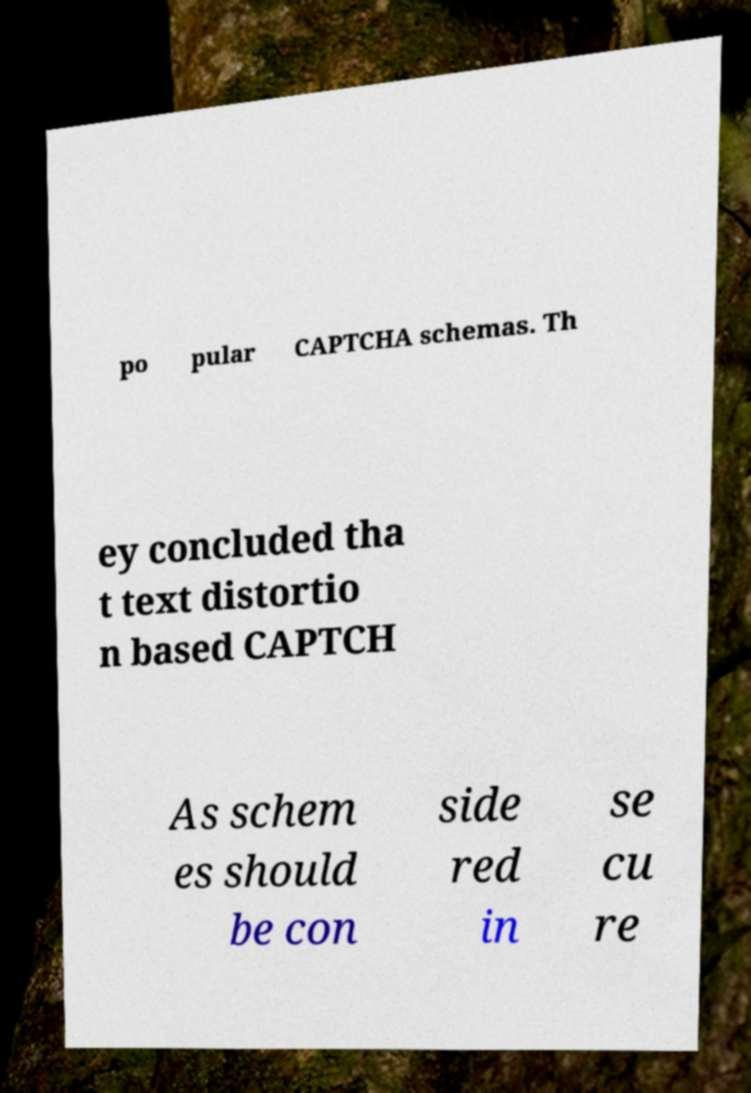Please read and relay the text visible in this image. What does it say? po pular CAPTCHA schemas. Th ey concluded tha t text distortio n based CAPTCH As schem es should be con side red in se cu re 